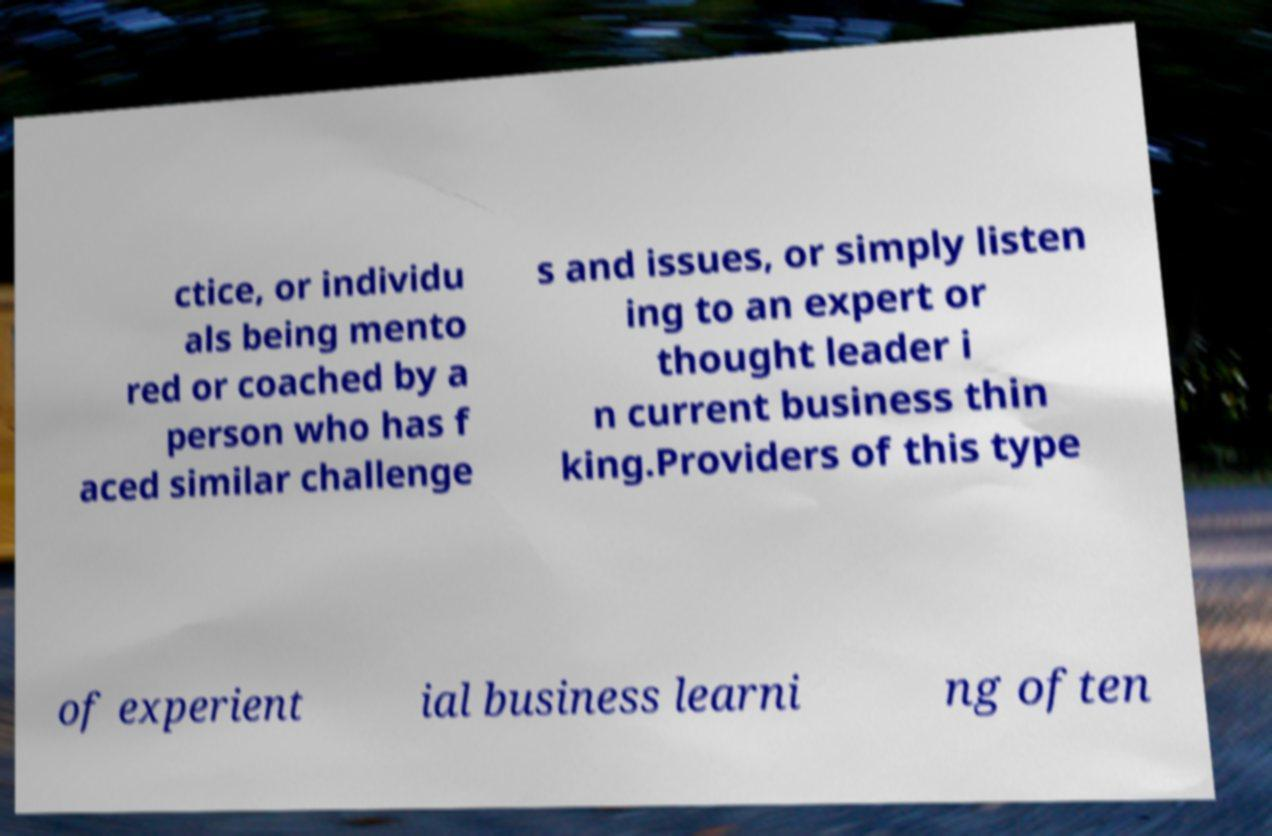There's text embedded in this image that I need extracted. Can you transcribe it verbatim? ctice, or individu als being mento red or coached by a person who has f aced similar challenge s and issues, or simply listen ing to an expert or thought leader i n current business thin king.Providers of this type of experient ial business learni ng often 